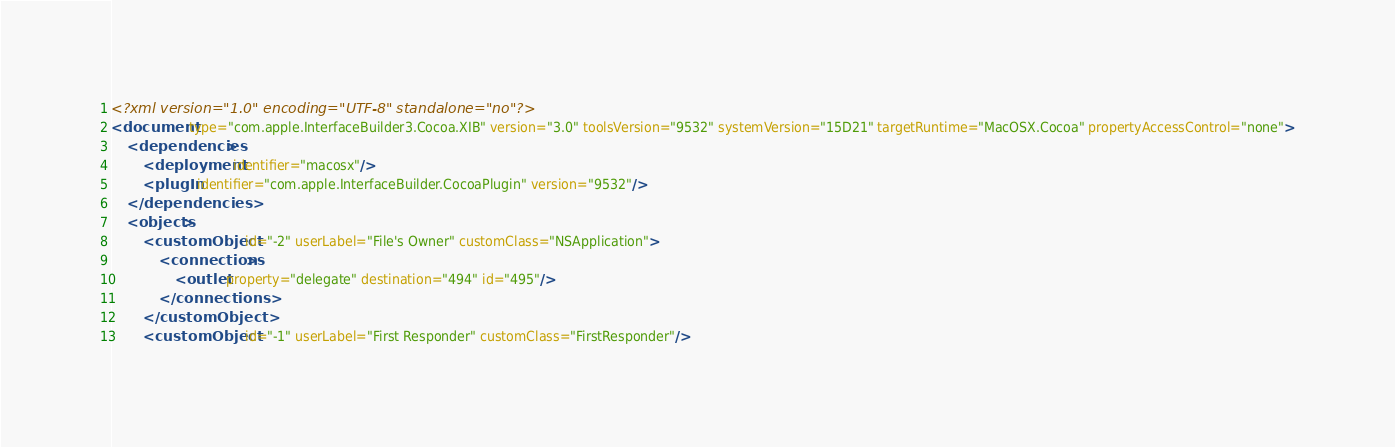<code> <loc_0><loc_0><loc_500><loc_500><_XML_><?xml version="1.0" encoding="UTF-8" standalone="no"?>
<document type="com.apple.InterfaceBuilder3.Cocoa.XIB" version="3.0" toolsVersion="9532" systemVersion="15D21" targetRuntime="MacOSX.Cocoa" propertyAccessControl="none">
    <dependencies>
        <deployment identifier="macosx"/>
        <plugIn identifier="com.apple.InterfaceBuilder.CocoaPlugin" version="9532"/>
    </dependencies>
    <objects>
        <customObject id="-2" userLabel="File's Owner" customClass="NSApplication">
            <connections>
                <outlet property="delegate" destination="494" id="495"/>
            </connections>
        </customObject>
        <customObject id="-1" userLabel="First Responder" customClass="FirstResponder"/></code> 